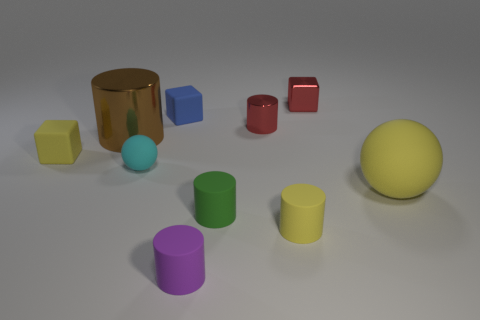Subtract all red cubes. How many cubes are left? 2 Subtract all yellow cylinders. How many cylinders are left? 4 Subtract 2 cylinders. How many cylinders are left? 3 Subtract all balls. How many objects are left? 8 Subtract all cyan blocks. Subtract all gray balls. How many blocks are left? 3 Subtract all red blocks. Subtract all tiny rubber balls. How many objects are left? 8 Add 7 red shiny cylinders. How many red shiny cylinders are left? 8 Add 6 tiny yellow matte things. How many tiny yellow matte things exist? 8 Subtract 1 yellow cylinders. How many objects are left? 9 